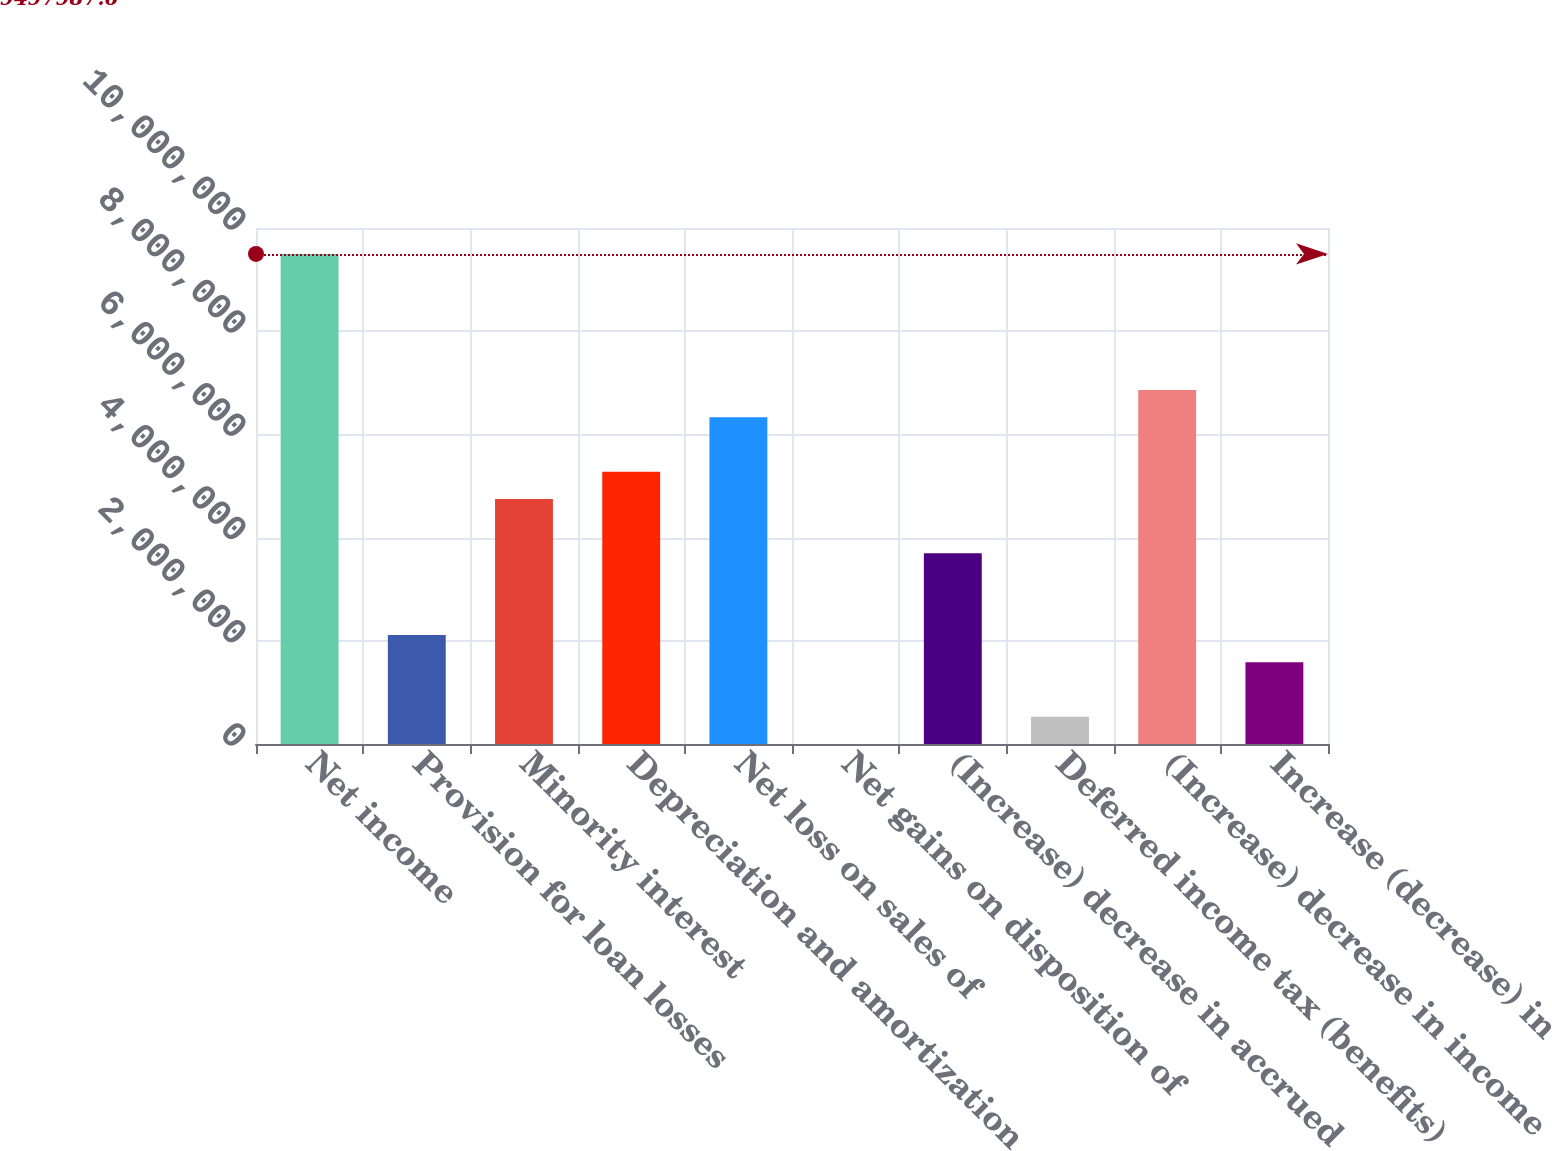Convert chart to OTSL. <chart><loc_0><loc_0><loc_500><loc_500><bar_chart><fcel>Net income<fcel>Provision for loan losses<fcel>Minority interest<fcel>Depreciation and amortization<fcel>Net loss on sales of<fcel>Net gains on disposition of<fcel>(Increase) decrease in accrued<fcel>Deferred income tax (benefits)<fcel>(Increase) decrease in income<fcel>Increase (decrease) in<nl><fcel>9.49799e+06<fcel>2.11196e+06<fcel>4.74982e+06<fcel>5.2774e+06<fcel>6.33255e+06<fcel>1661<fcel>3.69468e+06<fcel>529235<fcel>6.86012e+06<fcel>1.58438e+06<nl></chart> 